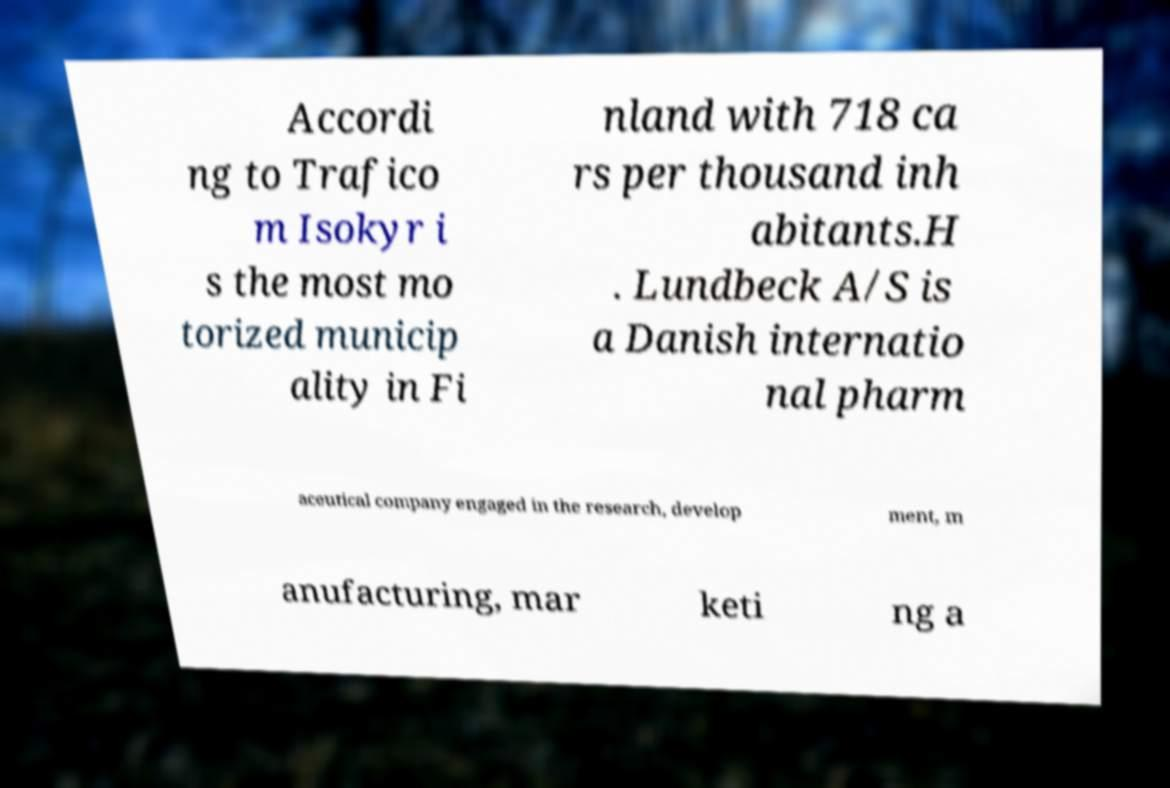I need the written content from this picture converted into text. Can you do that? Accordi ng to Trafico m Isokyr i s the most mo torized municip ality in Fi nland with 718 ca rs per thousand inh abitants.H . Lundbeck A/S is a Danish internatio nal pharm aceutical company engaged in the research, develop ment, m anufacturing, mar keti ng a 